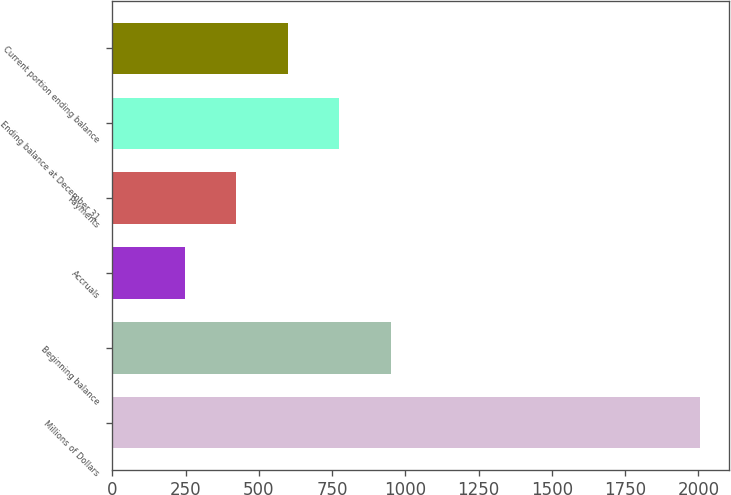<chart> <loc_0><loc_0><loc_500><loc_500><bar_chart><fcel>Millions of Dollars<fcel>Beginning balance<fcel>Accruals<fcel>Payments<fcel>Ending balance at December 31<fcel>Current portion ending balance<nl><fcel>2005<fcel>950.2<fcel>247<fcel>422.8<fcel>774.4<fcel>598.6<nl></chart> 